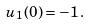<formula> <loc_0><loc_0><loc_500><loc_500>u _ { 1 } ( 0 ) = - 1 \, .</formula> 